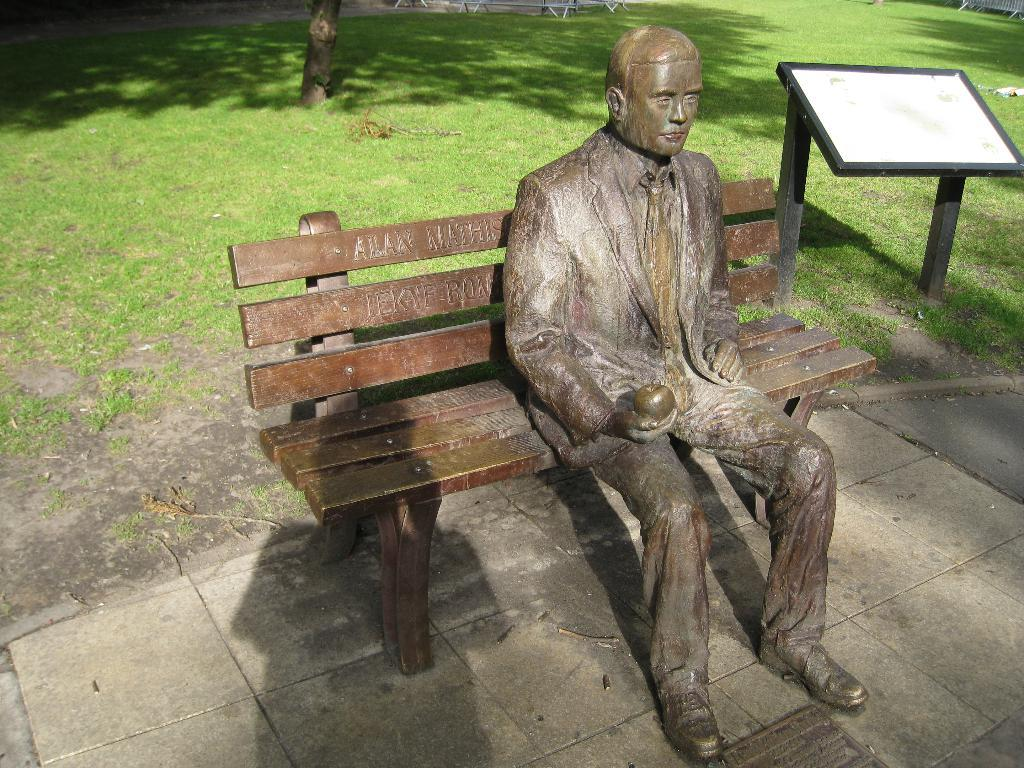What is the main subject of the image? There is a statue sitting on a bench in the image. What can be seen in the background of the image? There is a board and a tree visible in the background of the image. What type of ground is visible in the image? There is grass visible on the ground in the image. What type of stocking is the statue wearing on its legs in the image? The statue does not have legs, nor is it wearing any stockings in the image. 